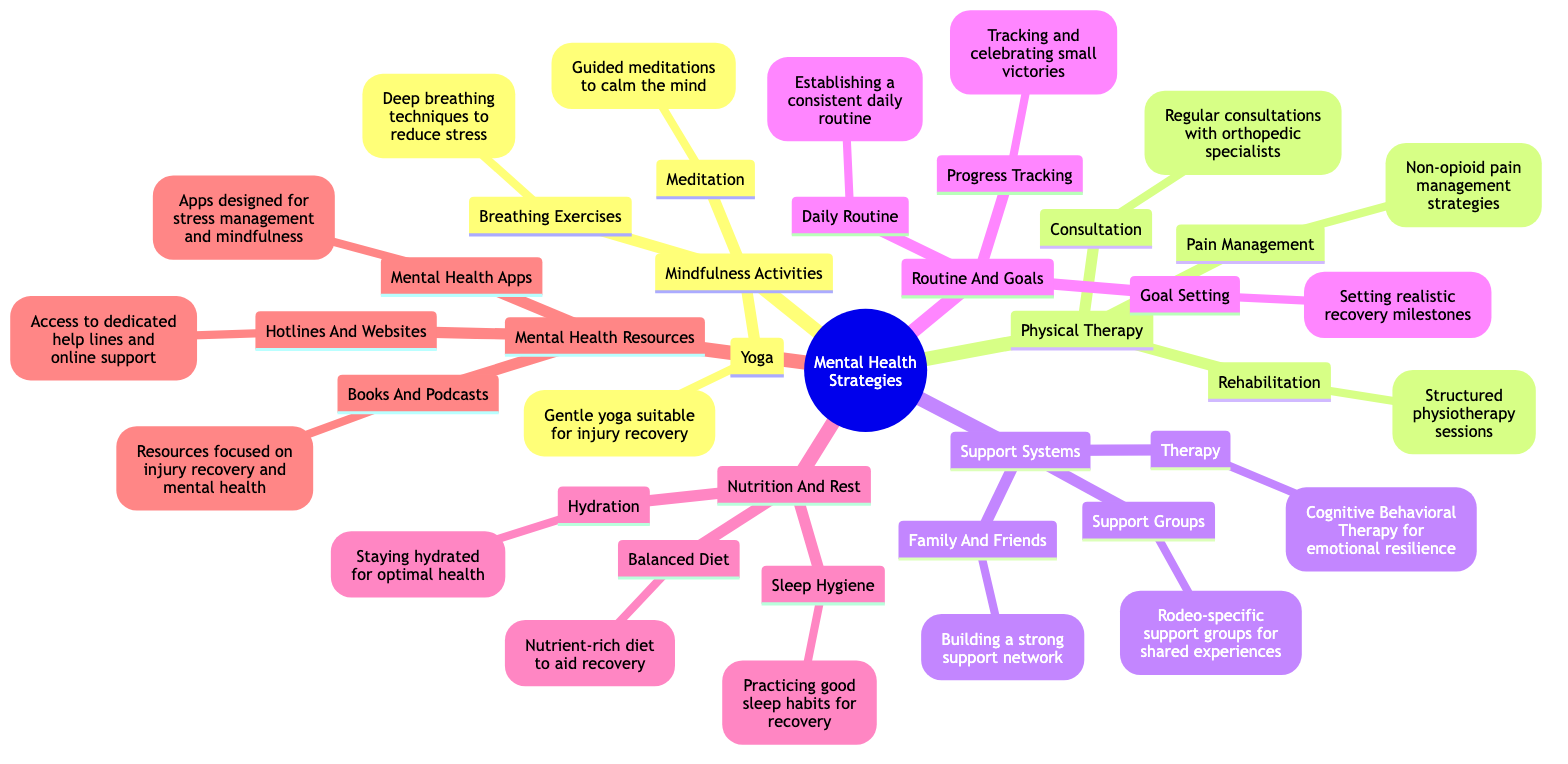What are the three categories of mental health strategies listed in the diagram? The diagram shows five main categories: Mindfulness Activities, Physical Therapy, Support Systems, Routine and Goals, Nutrition and Rest, and Mental Health Resources. By counting the distinct main nodes, we find that the answer is five.
Answer: Five Which activity is suggested under Mindfulness Activities? The diagram illustrates three activities under Mindfulness Activities: Meditation, Breathing Exercises, and Yoga. Each activity is an individual node stemming from the main category. Choosing any of these is correct, but to provide one example, Meditation is mentioned.
Answer: Meditation How many strategies are included under Nutrition and Rest? Under Nutrition and Rest, there are three components: Balanced Diet, Hydration, and Sleep Hygiene. These three are listed as separate strategies branching from the Nutrition and Rest node. Thus, counting these gives three.
Answer: Three What type of therapy is suggested as part of Support Systems? Within the Support Systems category, Cognitive Behavioral Therapy is specifically mentioned as a strategy aimed at enhancing emotional resilience. This therapy type is one of the three strategies listed under the Support Systems.
Answer: Cognitive Behavioral Therapy What is the purpose of the Progress Tracking node? The Progress Tracking node mentions tracking and celebrating small victories as a way to support recovery. This indicates that the purpose of this node is to motivate and encourage individuals during their injury recovery journey, as it highlights positive milestones.
Answer: Tracking and celebrating small victories Which node is associated with a therapist? The Therapy node is related to a therapist, as it mentions Cognitive Behavioral Therapy which typically involves a trained mental health professional. This association directly links therapists to the therapeutic support indicated in the diagram.
Answer: Therapy How many nodes are there under Mental Health Resources? The Mental Health Resources category contains three nodes: Books and Podcasts, Hotlines and Websites, and Mental Health Apps. Counting each of these gives a total of three.
Answer: Three What type of support does the Family and Friends node emphasize? The Family and Friends node emphasizes building a strong support network. This node indicates the importance of familial and social support in the recovery process.
Answer: Building a strong support network Which mindfulness activity is suitable for injury recovery? The Yoga node under Mindfulness Activities specifies that gentle yoga is suitable for injury recovery. This directly addresses the suitability of the listed activity for individuals recovering from injuries.
Answer: Gentle yoga suitable for injury recovery 